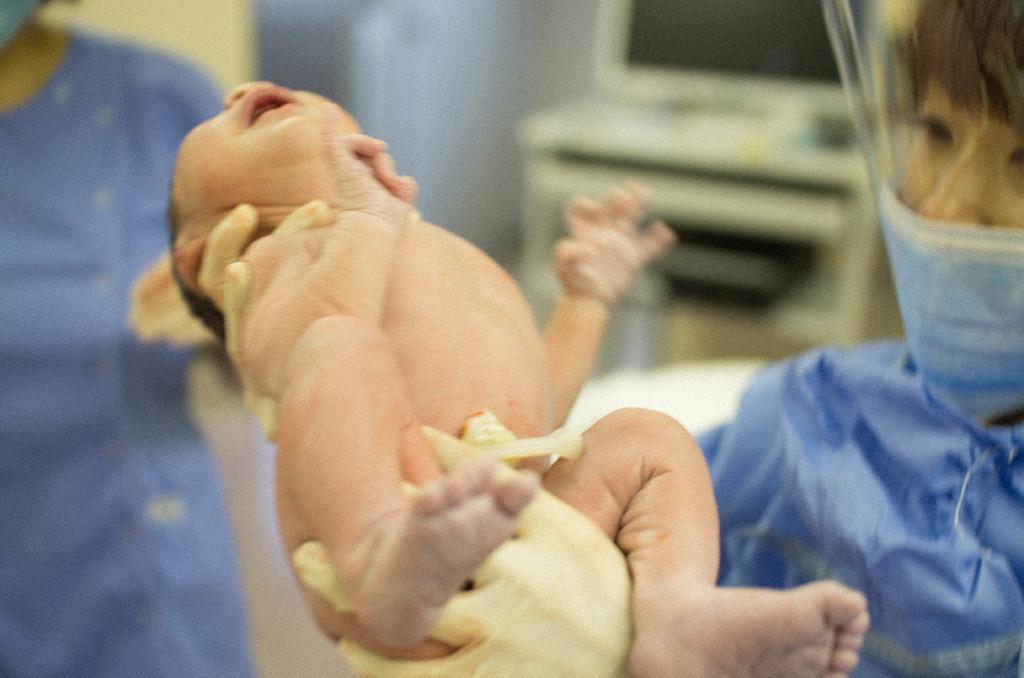How would you summarize this image in a sentence or two? In this image we can see a person holding a baby. On the left there is another person standing. In the background there is a computer placed on the stand. 